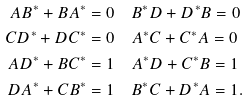<formula> <loc_0><loc_0><loc_500><loc_500>A B ^ { \ast } + B A ^ { \ast } & = 0 \quad B ^ { * } D + D ^ { * } B = 0 \\ C D ^ { \ast } + D C ^ { \ast } & = 0 \quad A ^ { * } C + C ^ { * } A = 0 \\ A D ^ { \ast } + B C ^ { \ast } & = 1 \quad A ^ { * } D + C ^ { * } B = 1 \\ D A ^ { \ast } + C B ^ { \ast } & = 1 \quad B ^ { * } C + D ^ { * } A = 1 . \\</formula> 